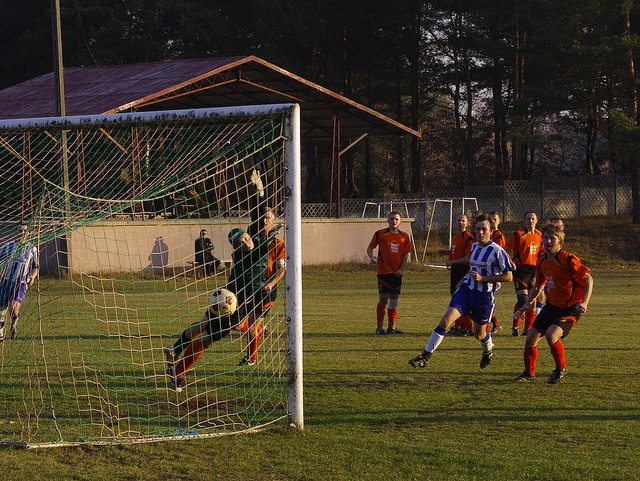Describe the objects in this image and their specific colors. I can see people in black, maroon, and olive tones, people in black, gray, olive, and maroon tones, people in black, navy, maroon, and olive tones, people in black, maroon, olive, and gray tones, and people in black, gray, darkgray, and olive tones in this image. 